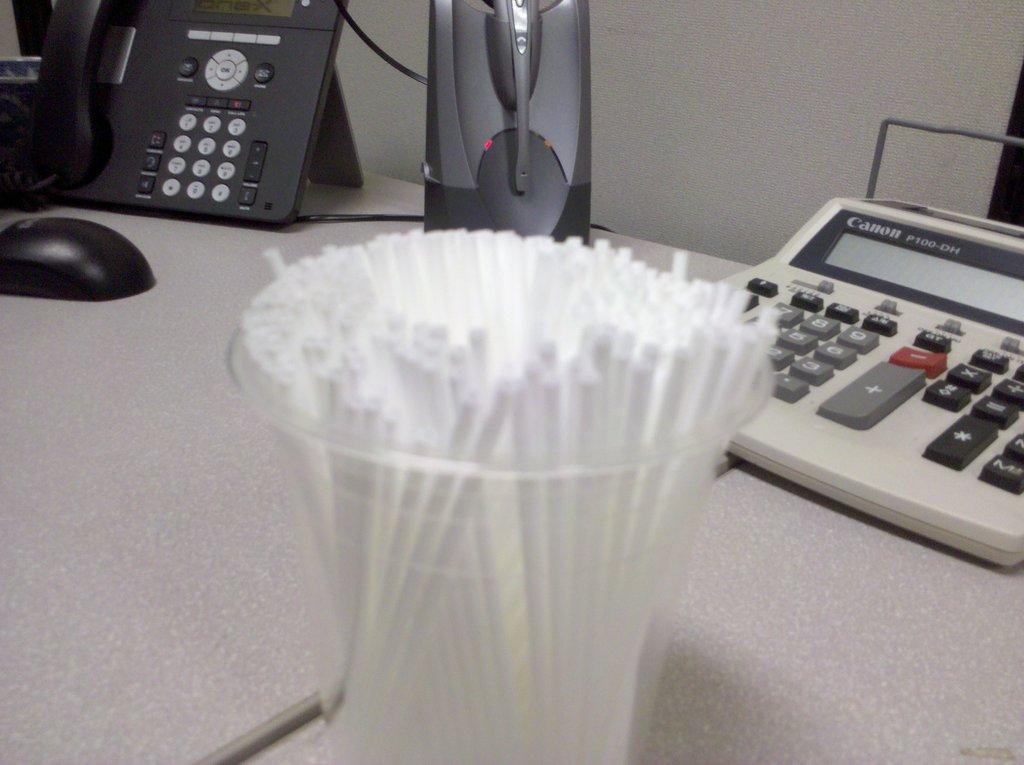<image>
Share a concise interpretation of the image provided. a calculator on the right made by Canon 